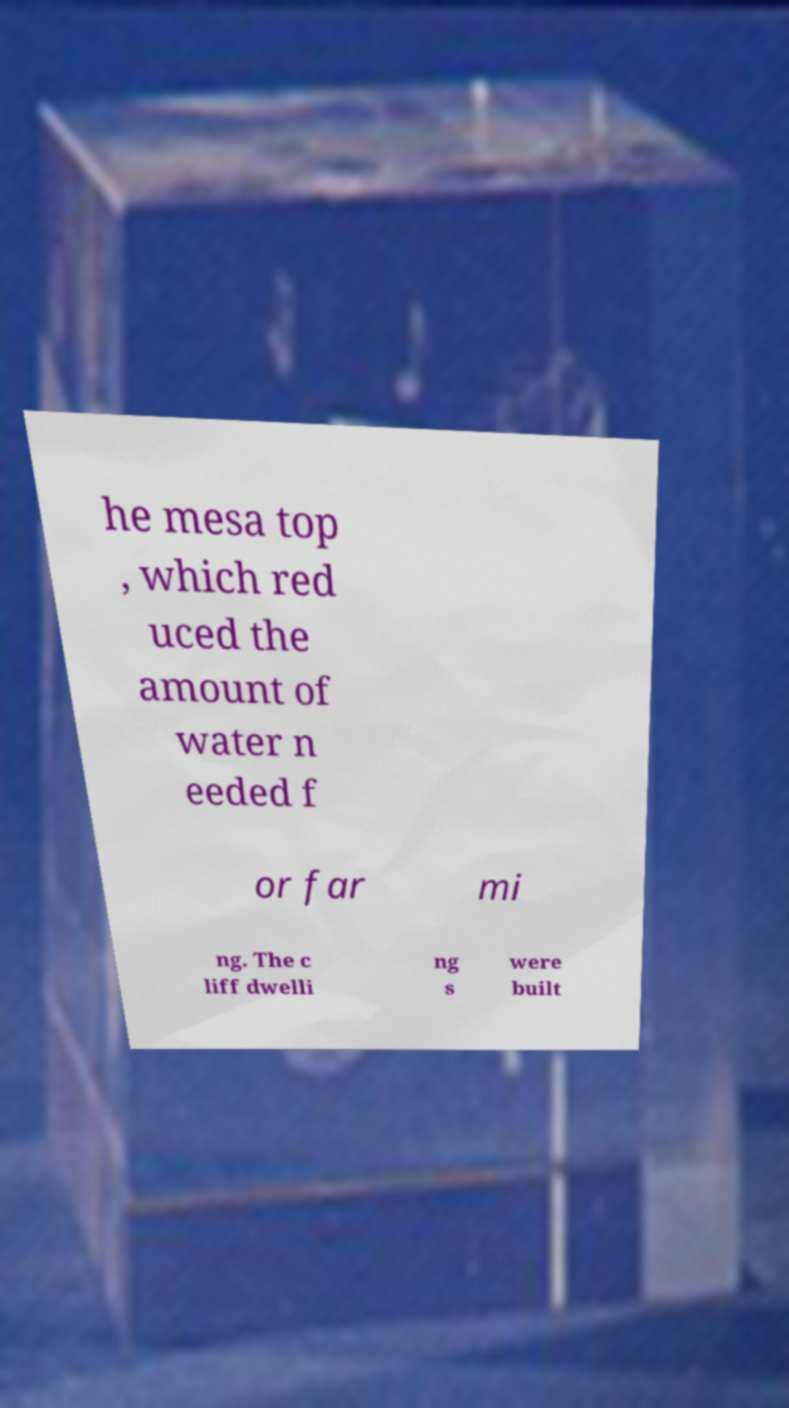Please read and relay the text visible in this image. What does it say? he mesa top , which red uced the amount of water n eeded f or far mi ng. The c liff dwelli ng s were built 